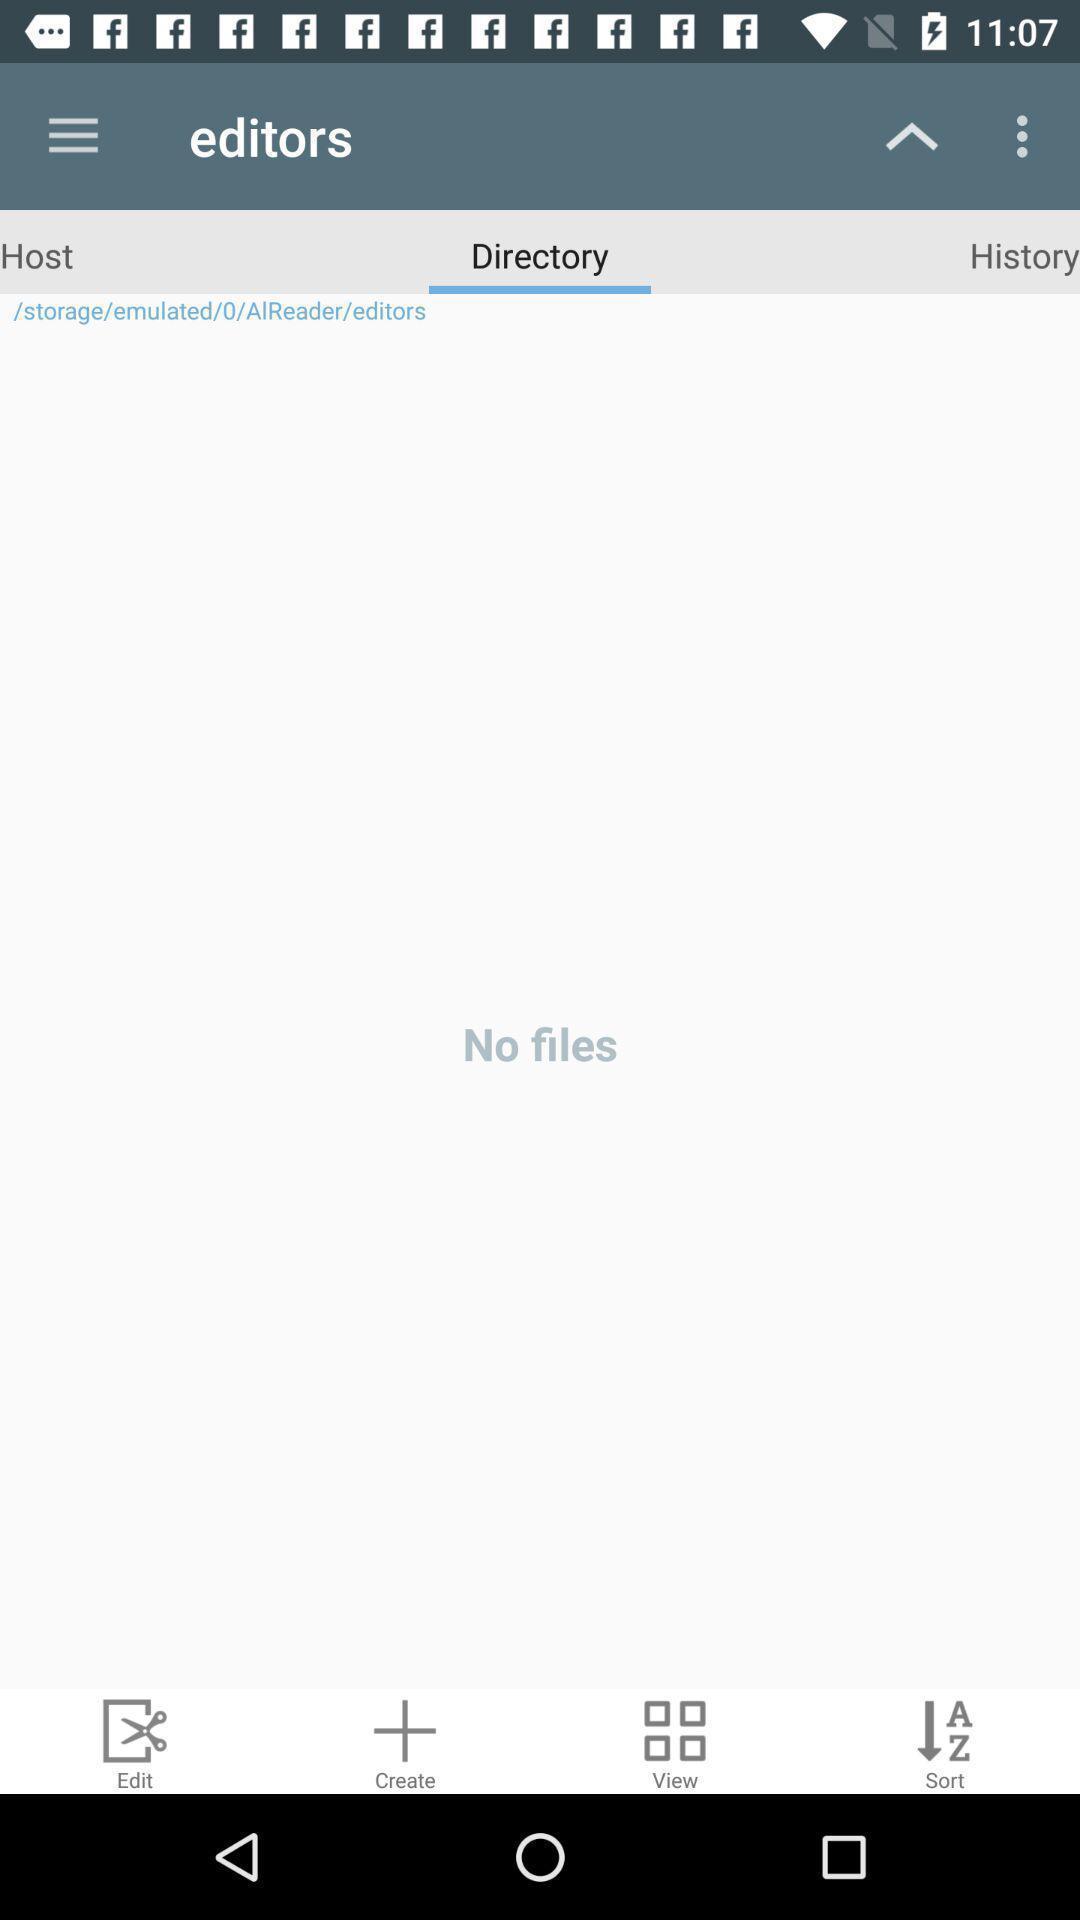Describe the key features of this screenshot. Screen displaying the empty files in a directory. 